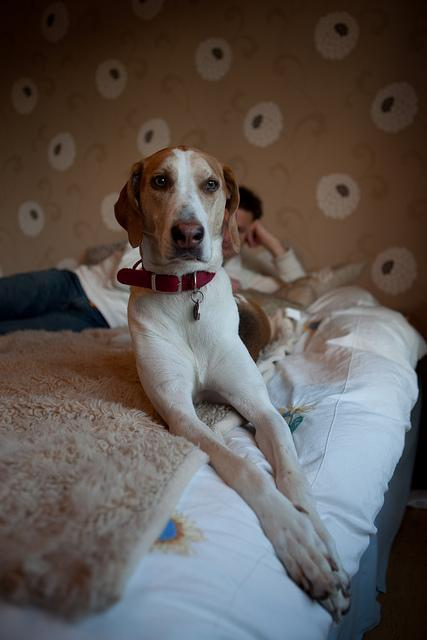What is the purpose of the item tied around his neck?

Choices:
A) choking
B) fashion
C) identification
D) breathing identification 